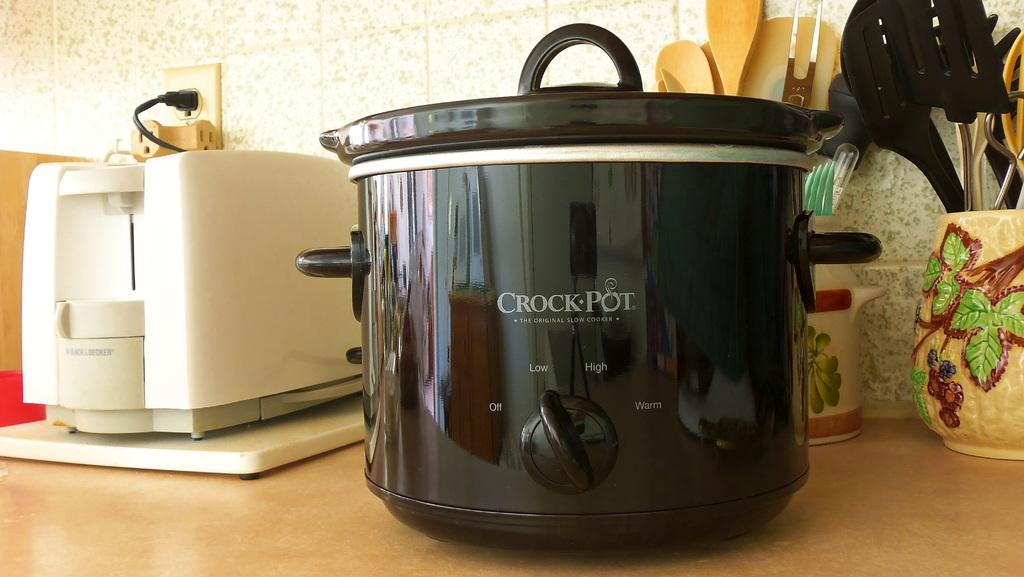Provide a one-sentence caption for the provided image. Black Crock Pot with the option to turn it high or low. 